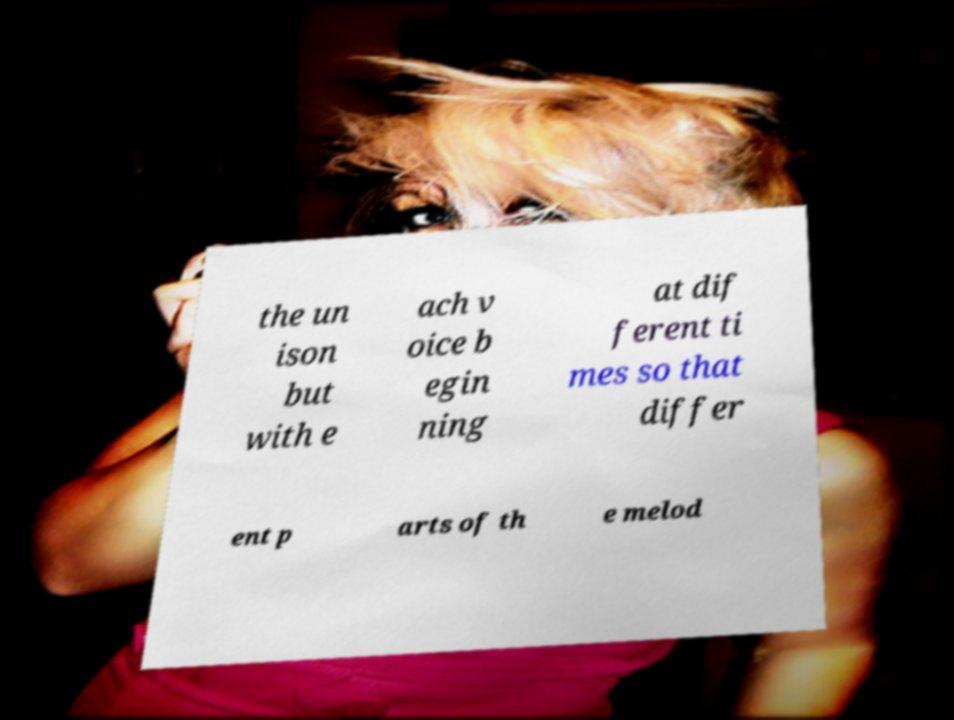What messages or text are displayed in this image? I need them in a readable, typed format. the un ison but with e ach v oice b egin ning at dif ferent ti mes so that differ ent p arts of th e melod 